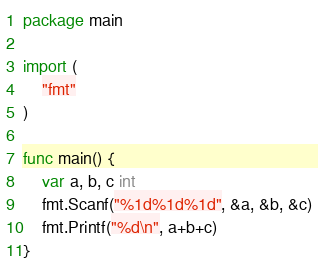<code> <loc_0><loc_0><loc_500><loc_500><_Go_>package main

import (
	"fmt"
)

func main() {
	var a, b, c int
	fmt.Scanf("%1d%1d%1d", &a, &b, &c)
	fmt.Printf("%d\n", a+b+c)
}
</code> 